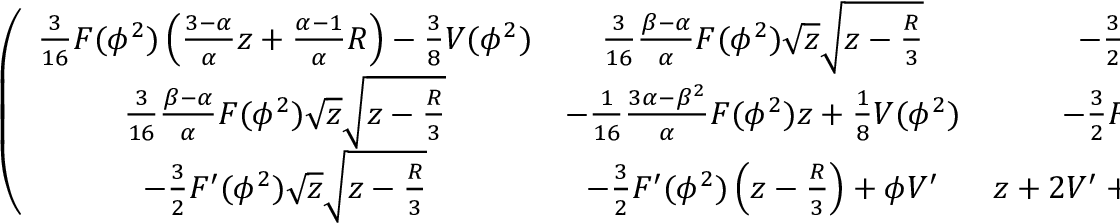<formula> <loc_0><loc_0><loc_500><loc_500>\left ( \begin{array} { c c c } { { { \frac { 3 } { 1 6 } } F ( \phi ^ { 2 } ) \left ( { \frac { 3 - \alpha } { \alpha } } z + { \frac { \alpha - 1 } { \alpha } } R \right ) - { \frac { 3 } { 8 } } V ( \phi ^ { 2 } ) } } & { { { \frac { 3 } { 1 6 } } { \frac { \beta - \alpha } { \alpha } } F ( \phi ^ { 2 } ) \sqrt { z } \sqrt { z - { \frac { R } { 3 } } } } } & { { - { \frac { 3 } { 2 } } F ^ { \prime } ( \phi ^ { 2 } ) \phi \sqrt { P _ { k } } \sqrt { P _ { k } - { \frac { R } { 3 } } } } } \\ { { { \frac { 3 } { 1 6 } } { \frac { \beta - \alpha } { \alpha } } F ( \phi ^ { 2 } ) \sqrt { z } \sqrt { z - { \frac { R } { 3 } } } } } & { { - { \frac { 1 } { 1 6 } } { \frac { 3 \alpha - \beta ^ { 2 } } { \alpha } } F ( \phi ^ { 2 } ) z + { \frac { 1 } { 8 } } V ( \phi ^ { 2 } ) } } & { { - { \frac { 3 } { 2 } } F ^ { \prime } ( \phi ^ { 2 } ) \phi \left ( z - { \frac { R } { 3 } } \right ) + \phi V ^ { \prime } } } \\ { { - { \frac { 3 } { 2 } } F ^ { \prime } ( \phi ^ { 2 } ) \sqrt { z } \sqrt { z - { \frac { R } { 3 } } } } } & { { - { \frac { 3 } { 2 } } F ^ { \prime } ( \phi ^ { 2 } ) \left ( z - { \frac { R } { 3 } } \right ) + \phi V ^ { \prime } } } & { { z + 2 V ^ { \prime } + 4 \phi ^ { 2 } V ^ { \prime \prime } - R ( 2 F ^ { \prime } + 4 \phi ^ { 2 } F ^ { \prime \prime } ) } } \end{array} \right ) .</formula> 